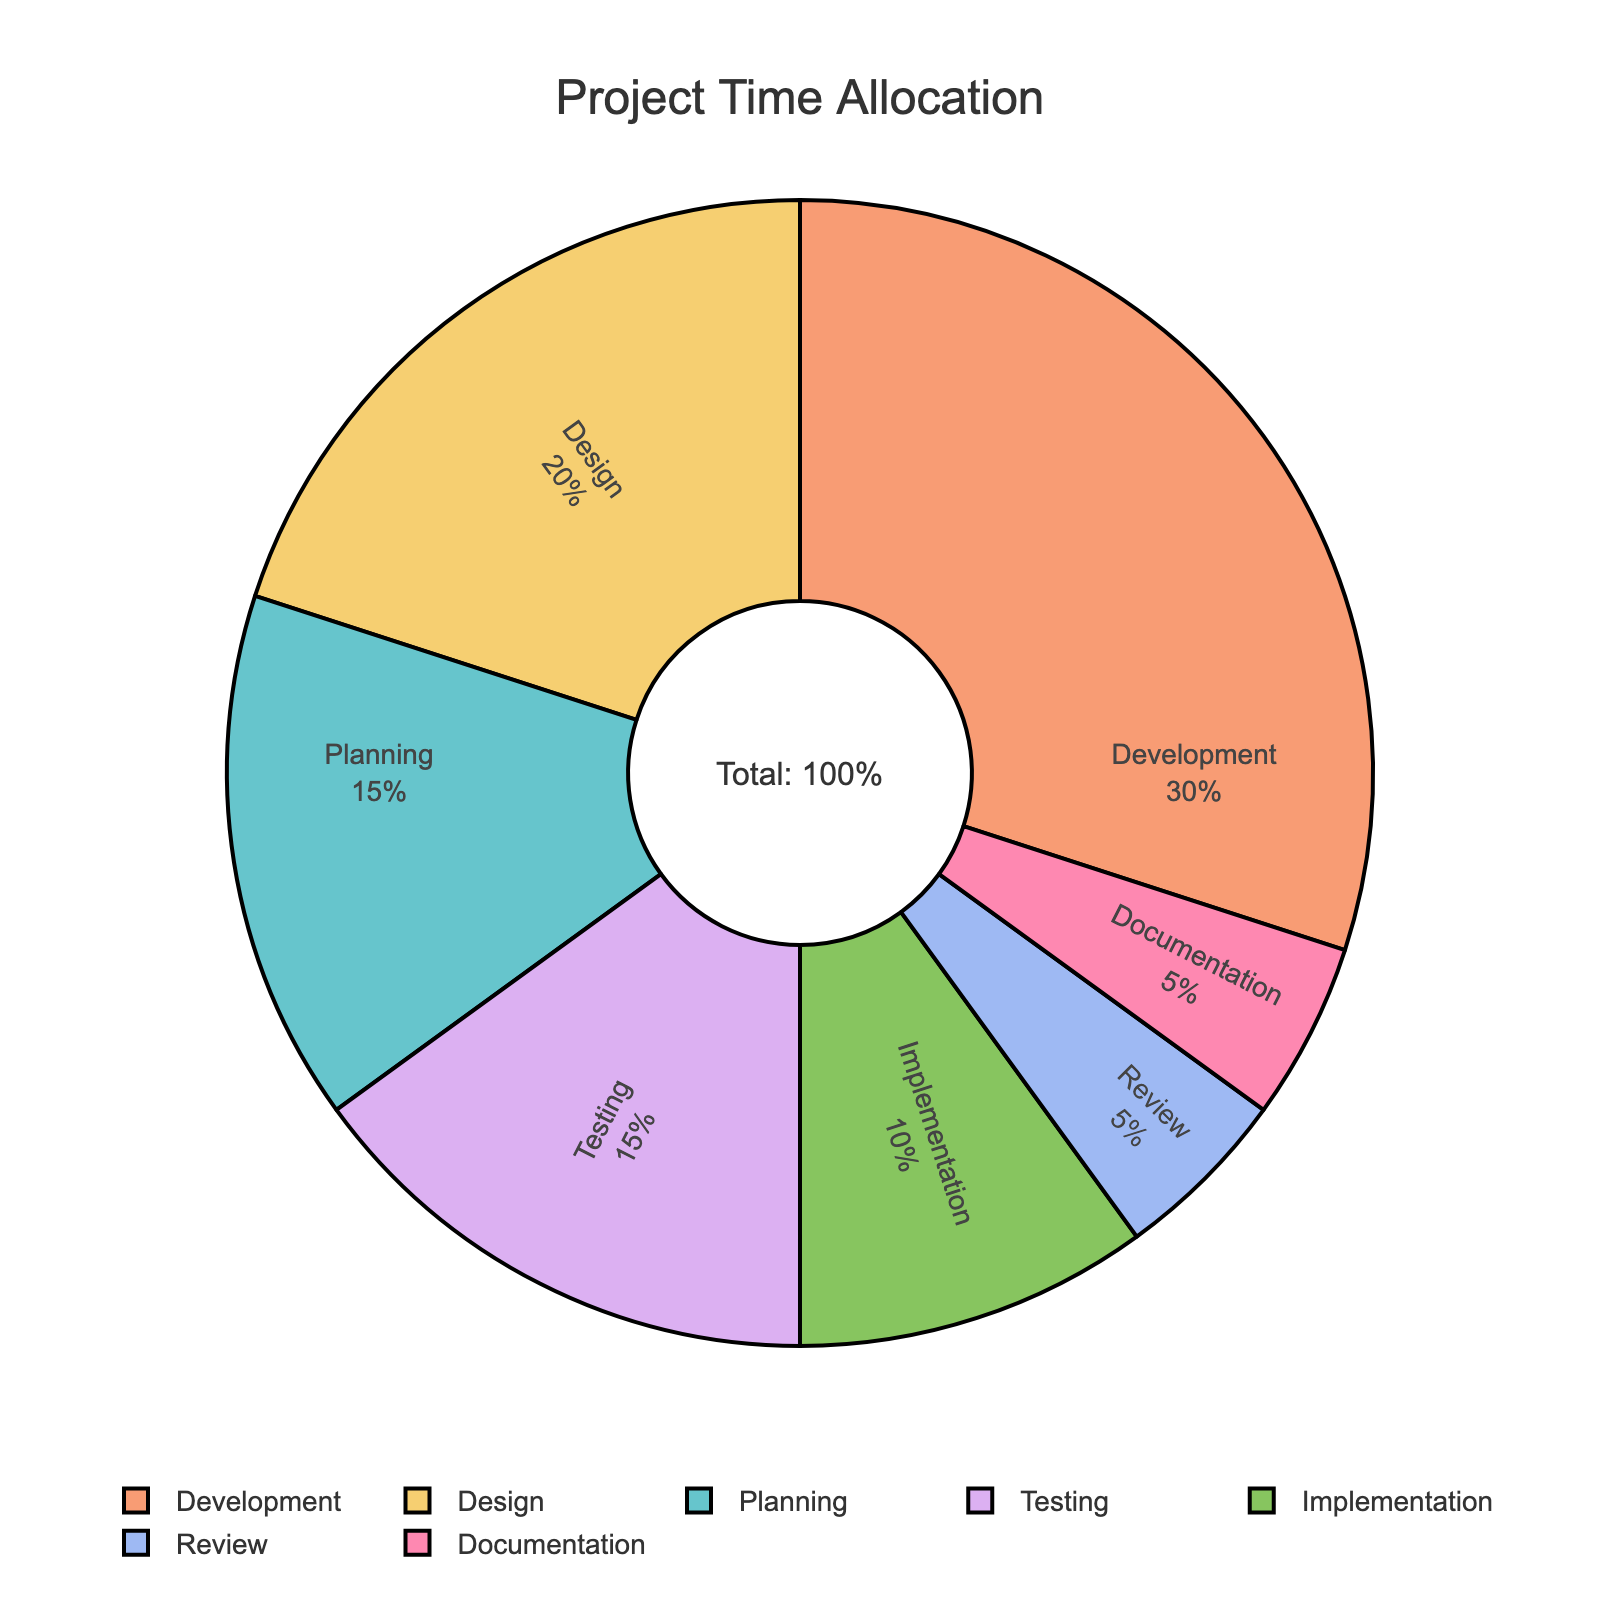Which phase has the highest percentage allocation? The pie chart shows that the "Development" phase has the largest portion of the chart at 30%.
Answer: Development What is the total percentage allocated to planning and testing phases combined? The percentages for "Planning" and "Testing" are 15% each. Adding these, 15% + 15% gives a total of 30%.
Answer: 30% How does the percentage of the design phase compare to the implementation phase? The "Design" phase is allocated 20% while the "Implementation" phase is allocated 10%. The design phase has a higher percentage by 10%.
Answer: Design is higher by 10% Which phases are allocated an equal percentage of the total time? The chart indicates that both "Planning" and "Testing" phases have an equal allocation of 15%, and "Review" and "Documentation" both have 5%.
Answer: Planning and Testing; Review and Documentation What is the combined percentage allocation of the phases with the lowest percentages? The phases with the lowest percentages are "Review" and "Documentation" at 5% each. Adding these, 5% + 5% gives a total of 10%.
Answer: 10% How much higher is the percentage of the development phase than the planning phase? The "Development" phase is allocated 30%, and the "Planning" phase is allocated 15%. The difference is 30% - 15% = 15%.
Answer: 15% What is the difference in percentage allocation between the highest and the lowest phases? The highest phase is the "Development" phase at 30%, and the lowest phases are "Review" and "Documentation" at 5% each. The difference is 30% - 5% = 25%.
Answer: 25% What is the percentage allocated to phases other than development? The "Development" phase is 30%, so the remaining is 100% - 30% which equals 70%.
Answer: 70% If you combined the design and implementation phases, what would be their total percentage allocation? The "Design" phase has 20%, and the "Implementation" phase has 10%. Adding these, 20% + 10% gives a combined total of 30%.
Answer: 30% 